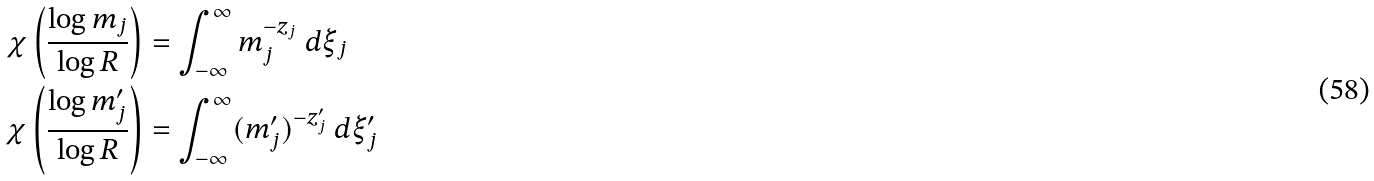Convert formula to latex. <formula><loc_0><loc_0><loc_500><loc_500>\chi \left ( \frac { \log m _ { j } } { \log R } \right ) & = \int _ { - \infty } ^ { \infty } m _ { j } ^ { - z _ { j } } \ d \xi _ { j } \\ \chi \left ( \frac { \log m ^ { \prime } _ { j } } { \log R } \right ) & = \int _ { - \infty } ^ { \infty } ( m ^ { \prime } _ { j } ) ^ { - z ^ { \prime } _ { j } } \ d \xi ^ { \prime } _ { j }</formula> 